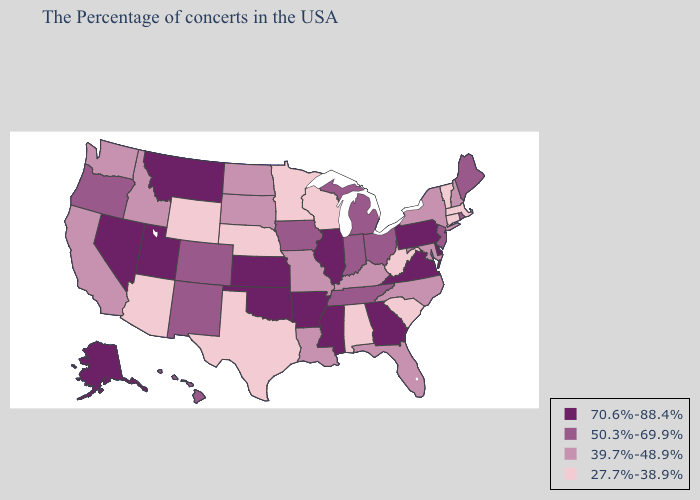Does Minnesota have the lowest value in the USA?
Write a very short answer. Yes. Name the states that have a value in the range 70.6%-88.4%?
Answer briefly. Delaware, Pennsylvania, Virginia, Georgia, Illinois, Mississippi, Arkansas, Kansas, Oklahoma, Utah, Montana, Nevada, Alaska. Which states have the lowest value in the South?
Be succinct. South Carolina, West Virginia, Alabama, Texas. Does South Dakota have the same value as New Mexico?
Be succinct. No. Which states hav the highest value in the MidWest?
Give a very brief answer. Illinois, Kansas. Name the states that have a value in the range 70.6%-88.4%?
Be succinct. Delaware, Pennsylvania, Virginia, Georgia, Illinois, Mississippi, Arkansas, Kansas, Oklahoma, Utah, Montana, Nevada, Alaska. Does Washington have the same value as New Mexico?
Answer briefly. No. Name the states that have a value in the range 50.3%-69.9%?
Write a very short answer. Maine, Rhode Island, New Jersey, Ohio, Michigan, Indiana, Tennessee, Iowa, Colorado, New Mexico, Oregon, Hawaii. What is the value of South Dakota?
Write a very short answer. 39.7%-48.9%. Does North Carolina have a higher value than Wyoming?
Give a very brief answer. Yes. Does the map have missing data?
Concise answer only. No. Which states hav the highest value in the West?
Concise answer only. Utah, Montana, Nevada, Alaska. What is the lowest value in the USA?
Be succinct. 27.7%-38.9%. Does the map have missing data?
Write a very short answer. No. What is the value of Utah?
Give a very brief answer. 70.6%-88.4%. 